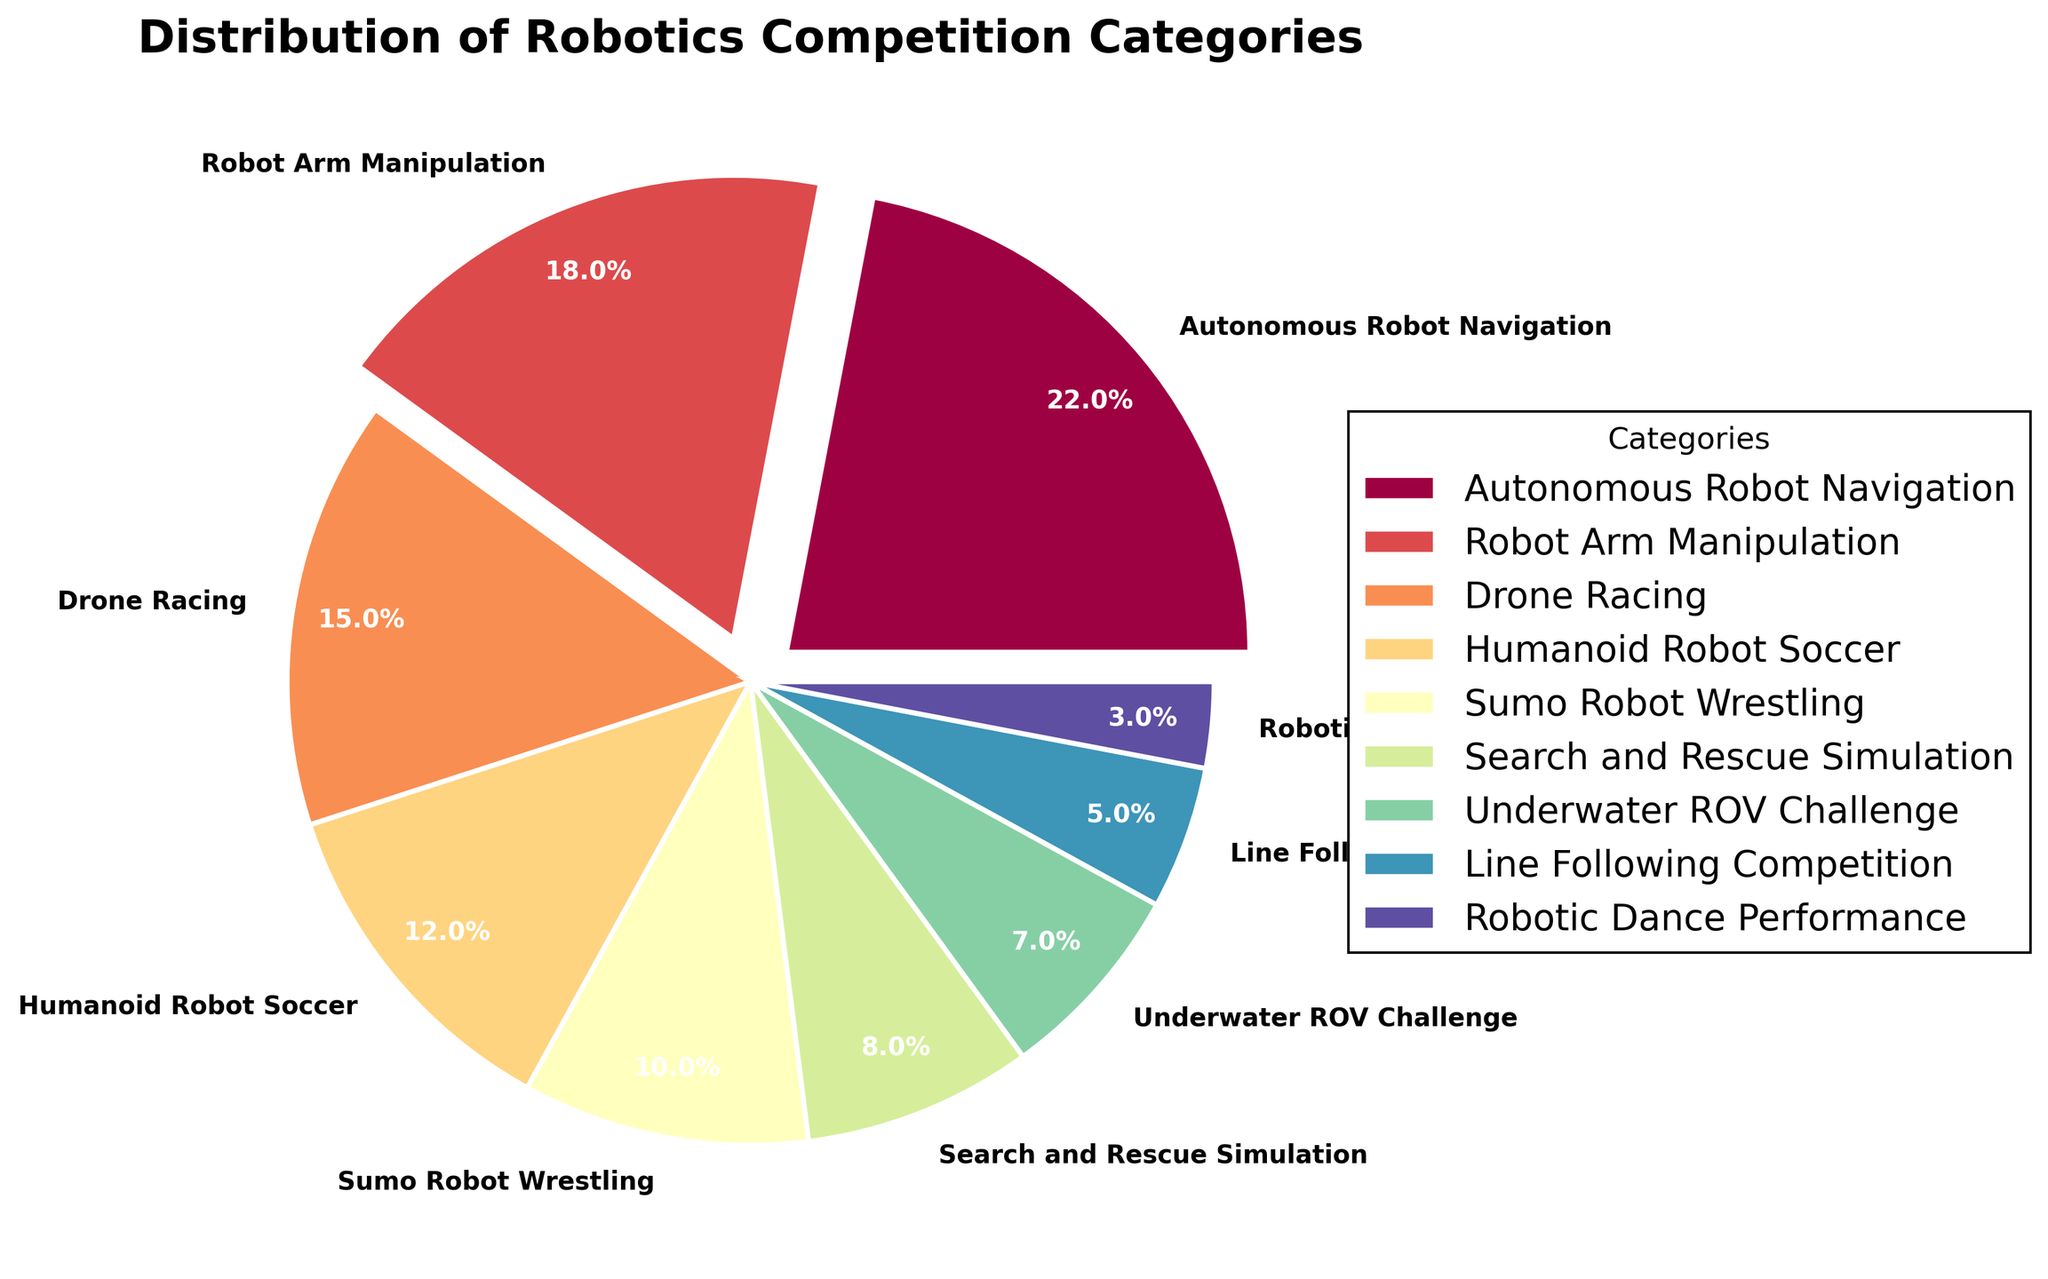What is the category with the highest percentage? The largest section in the pie chart is labeled "Autonomous Robot Navigation" with 22%
Answer: Autonomous Robot Navigation Which two categories have the closest percentage values? By comparing slices, "Sumo Robot Wrestling" (10%) and "Search and Rescue Simulation" (8%) have the smallest difference in percentages
Answer: Sumo Robot Wrestling and Search and Rescue Simulation What is the combined percentage of "Robot Arm Manipulation" and "Drone Racing"? "Robot Arm Manipulation" is 18% and "Drone Racing" is 15%. Their sum is 18% + 15% = 33%
Answer: 33% How many categories have a percentage higher than 10%? The categories with more than 10% are "Autonomous Robot Navigation" (22%), "Robot Arm Manipulation" (18%), "Drone Racing" (15%), and "Humanoid Robot Soccer" (12%), totaling 4 categories
Answer: 4 Which category has the smallest percentage, and what is it? The segment labeled as "Robotic Dance Performance" is the smallest with 3%
Answer: Robotic Dance Performance Compare the combined percentage of "Underwater ROV Challenge" and "Line Following Competition" to "Drone Racing". Which is greater? "Underwater ROV Challenge" is 7% and "Line Following Competition" is 5%. Their sum is 7% + 5% = 12%. "Drone Racing" itself is 15%. 15% is greater than 12%
Answer: Drone Racing is greater What is the total percentage of categories related to robots interacting with their environment (e.g., Navigation, Manipulation, Racing, Search and Rescue)? Adding percentages from "Autonomous Robot Navigation" (22%), "Robot Arm Manipulation" (18%), "Search and Rescue Simulation" (8%), and "Drone Racing" (15%) gives us 22% + 18% + 8% + 15% = 63%
Answer: 63% How much larger is the percentage of "Humanoid Robot Soccer" than "Line Following Competition"? "Humanoid Robot Soccer" is 12% and "Line Following Competition" is 5%. The difference is 12% - 5% = 7%
Answer: 7% Which category uses wedge colors, according to the pie chart, that is the first and last in the spectrum? The pie chart uses a colormap which starts with deep red and ends with dark blue. "Autonomous Robot Navigation" (the largest) likely uses the first color, and "Robotic Dance Performance" (smallest) likely uses the last color
Answer: Autonomous Robot Navigation and Robotic Dance Performance Identify two categories with a percentage difference of 10% or larger and specify that difference "Autonomous Robot Navigation" is 22% and "Sumo Robot Wrestling" is 10%. The difference is 22% - 10% = 12%
Answer: 12% 